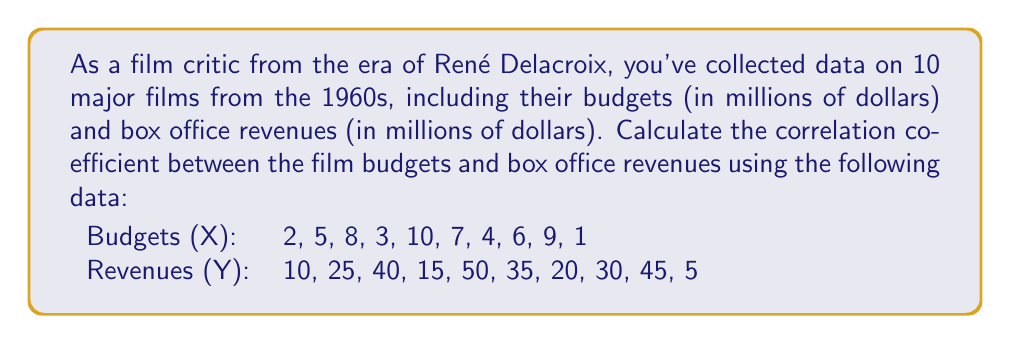Help me with this question. To calculate the correlation coefficient, we'll use the formula:

$$ r = \frac{n\sum xy - \sum x \sum y}{\sqrt{[n\sum x^2 - (\sum x)^2][n\sum y^2 - (\sum y)^2]}} $$

Where:
$n$ = number of data points
$x$ = budget values
$y$ = revenue values

Step 1: Calculate the sums and squared sums:
$n = 10$
$\sum x = 55$
$\sum y = 275$
$\sum xy = 1,830$
$\sum x^2 = 387$
$\sum y^2 = 10,275$

Step 2: Calculate $(\sum x)^2$ and $(\sum y)^2$:
$(\sum x)^2 = 3,025$
$(\sum y)^2 = 75,625$

Step 3: Apply the formula:

$$ r = \frac{10(1,830) - (55)(275)}{\sqrt{[10(387) - 3,025][10(10,275) - 75,625]}} $$

$$ r = \frac{18,300 - 15,125}{\sqrt{(3,870 - 3,025)(102,750 - 75,625)}} $$

$$ r = \frac{3,175}{\sqrt{(845)(27,125)}} $$

$$ r = \frac{3,175}{\sqrt{22,920,625}} $$

$$ r = \frac{3,175}{4,787.96} $$

$$ r \approx 0.9970 $$
Answer: $0.9970$ 